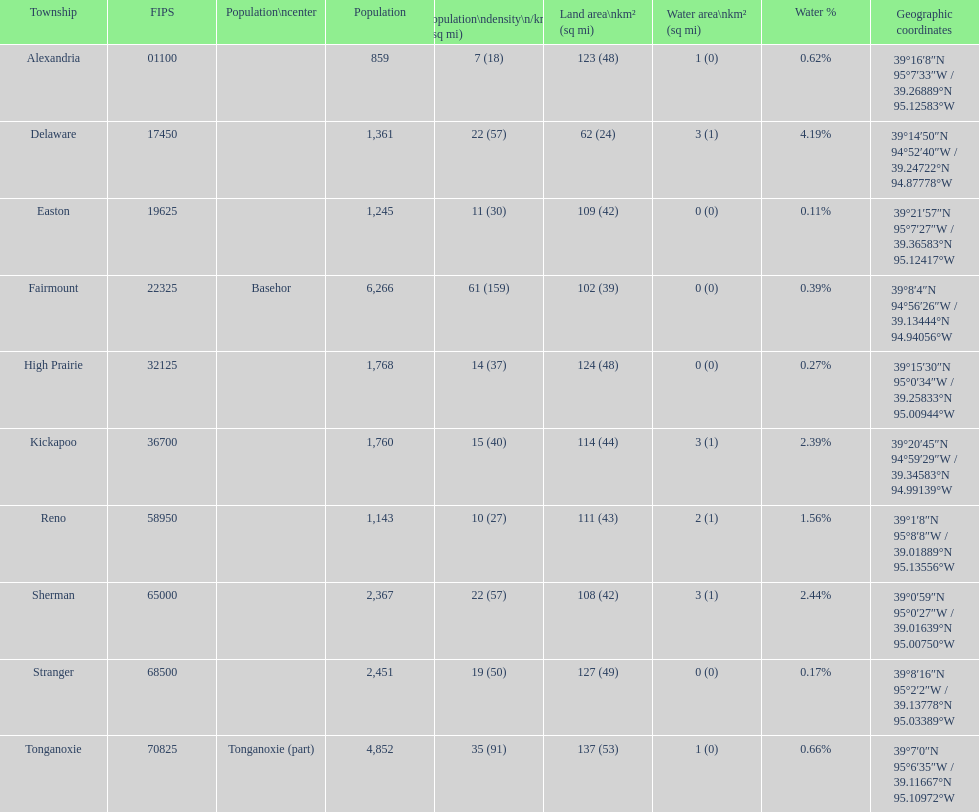Which township possesses the minimum land area? Delaware. 